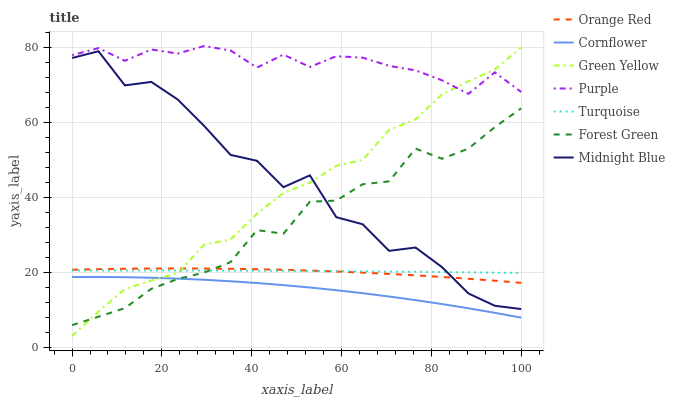Does Cornflower have the minimum area under the curve?
Answer yes or no. Yes. Does Purple have the maximum area under the curve?
Answer yes or no. Yes. Does Turquoise have the minimum area under the curve?
Answer yes or no. No. Does Turquoise have the maximum area under the curve?
Answer yes or no. No. Is Turquoise the smoothest?
Answer yes or no. Yes. Is Midnight Blue the roughest?
Answer yes or no. Yes. Is Midnight Blue the smoothest?
Answer yes or no. No. Is Turquoise the roughest?
Answer yes or no. No. Does Turquoise have the lowest value?
Answer yes or no. No. Does Purple have the highest value?
Answer yes or no. Yes. Does Turquoise have the highest value?
Answer yes or no. No. Is Cornflower less than Turquoise?
Answer yes or no. Yes. Is Turquoise greater than Cornflower?
Answer yes or no. Yes. Does Green Yellow intersect Turquoise?
Answer yes or no. Yes. Is Green Yellow less than Turquoise?
Answer yes or no. No. Is Green Yellow greater than Turquoise?
Answer yes or no. No. Does Cornflower intersect Turquoise?
Answer yes or no. No. 